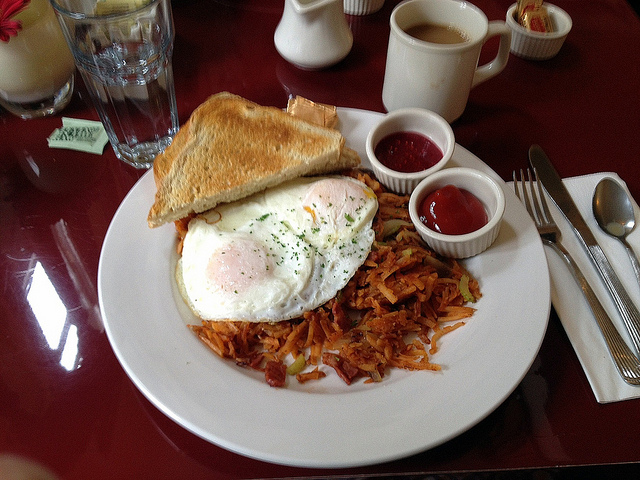Create a fictional short story inspired by this breakfast plate. Once upon a time in a quaint village at the edge of a sprawling forest, lived an old baker named Mr. Oliver, renowned for his exceptional culinary skills. One crisp morning, as the sun beamed down, Mr. Oliver decided to create a breakfast masterpiece for his best friend, Mrs. Hazel, who was visiting from the city. He woke up early, gathering the freshest ingredients: eggs from his playful hens, potatoes from his lush garden, and bread baked with grains from the local mill. As he cooked, the kitchen filled with mouth-watering aromas, drawing Mrs. Hazel to the table with a sense of anticipation. When Alex took the first bite, he was transported back to his childhood when his grandma used to make similar breakfasts. The crispy hash browns reminded him of the family farm's harvest festival, and the sunny-side-up eggs brought back memories of lazy summer breakfasts under the apple tree. Mrs. Hazel, touched by the love and care infused into each bite, felt the warmth of old friendship and new memories intertwining. They spent the morning reminiscing, laughing, and dreaming of more shared meals to come. This breakfast, with its simple ingredients and rich flavors, had woven a new chapter in their longstanding friendship—one of joy, comfort, and the magic of good food shared with loved ones. 